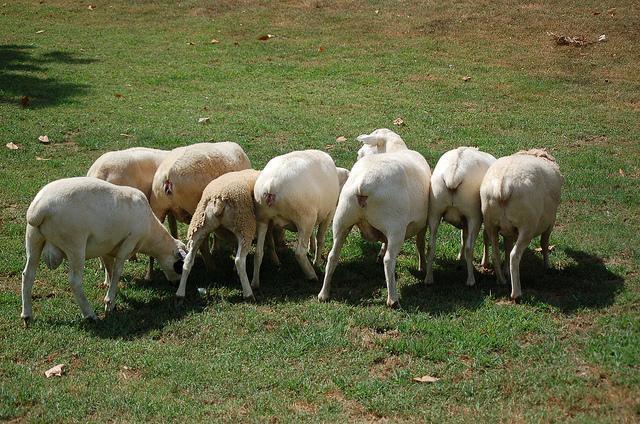How many sheep are there?
Give a very brief answer. 8. How many sheep are facing the camera?
Give a very brief answer. 0. How many sheep can be seen?
Give a very brief answer. 8. How many of the people wear stripes?
Give a very brief answer. 0. 